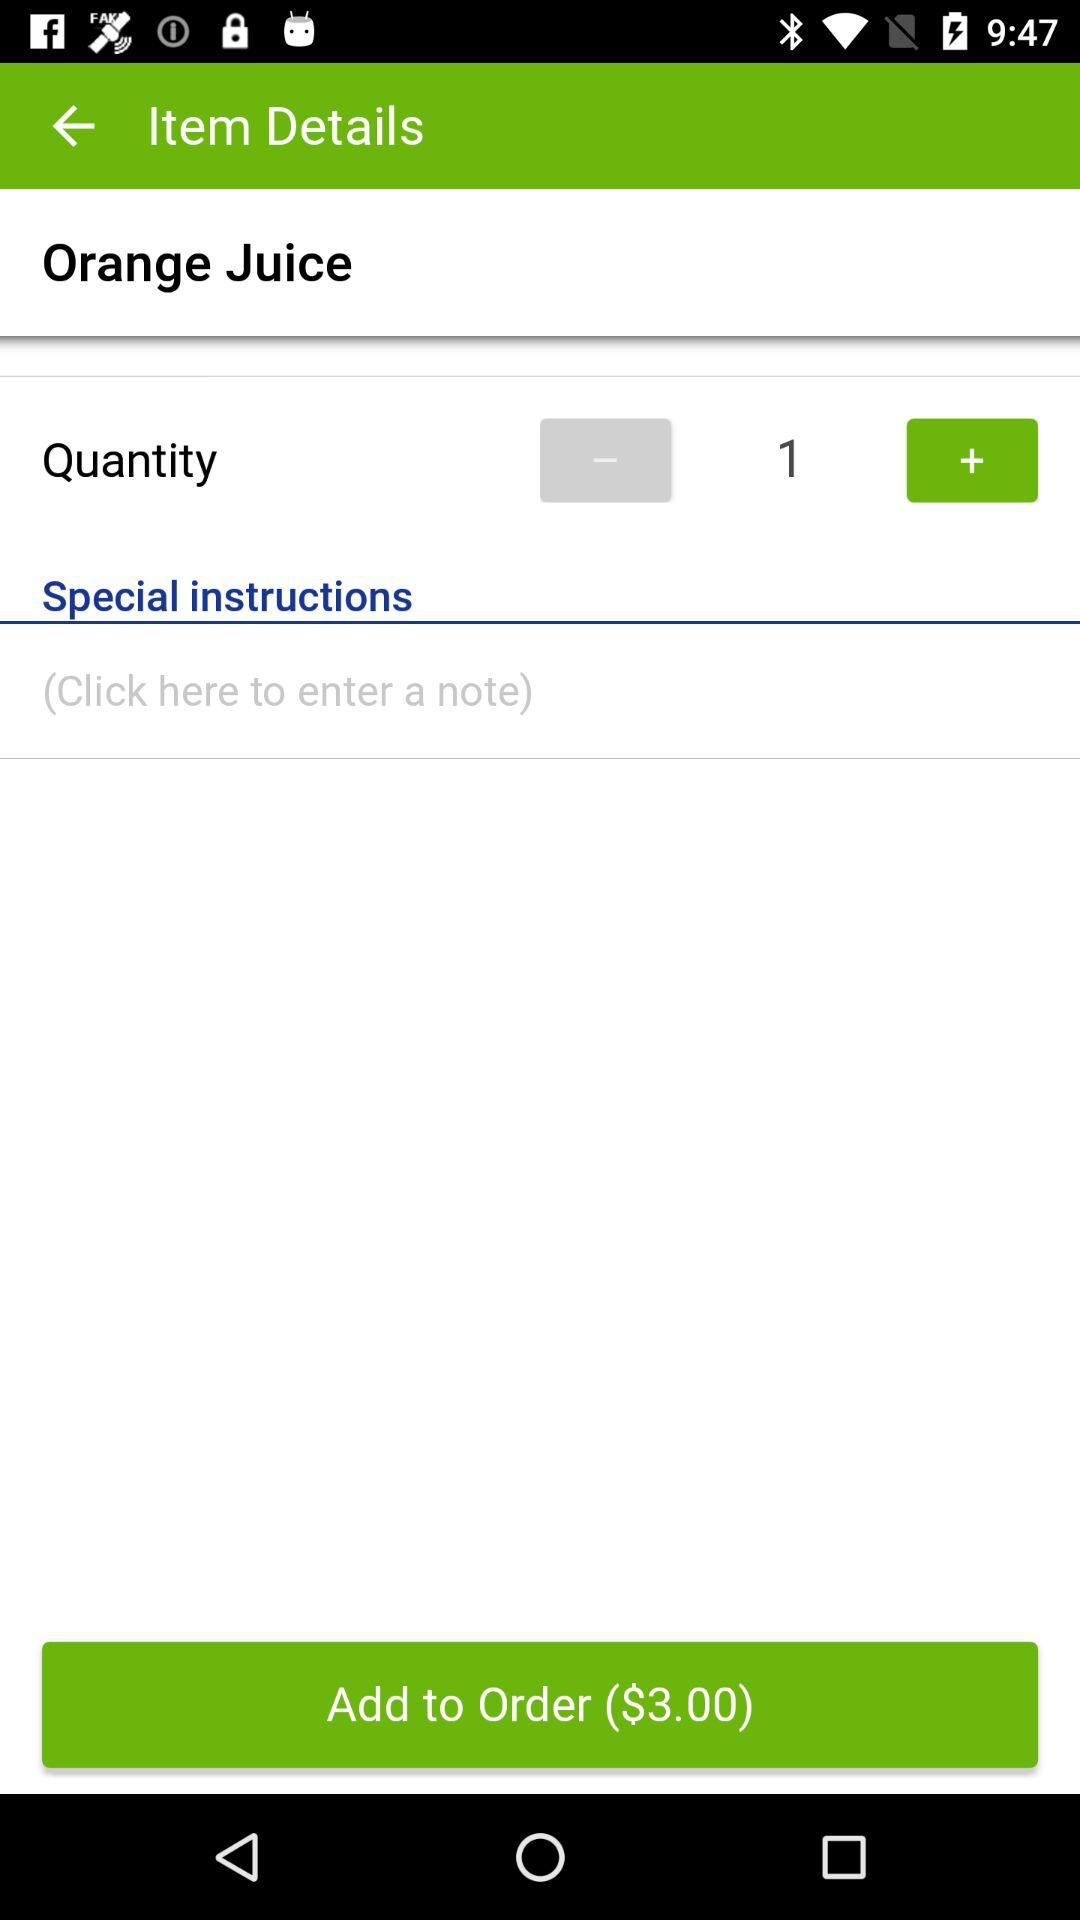What is the price of the juice? The price of the juice is $3.00. 